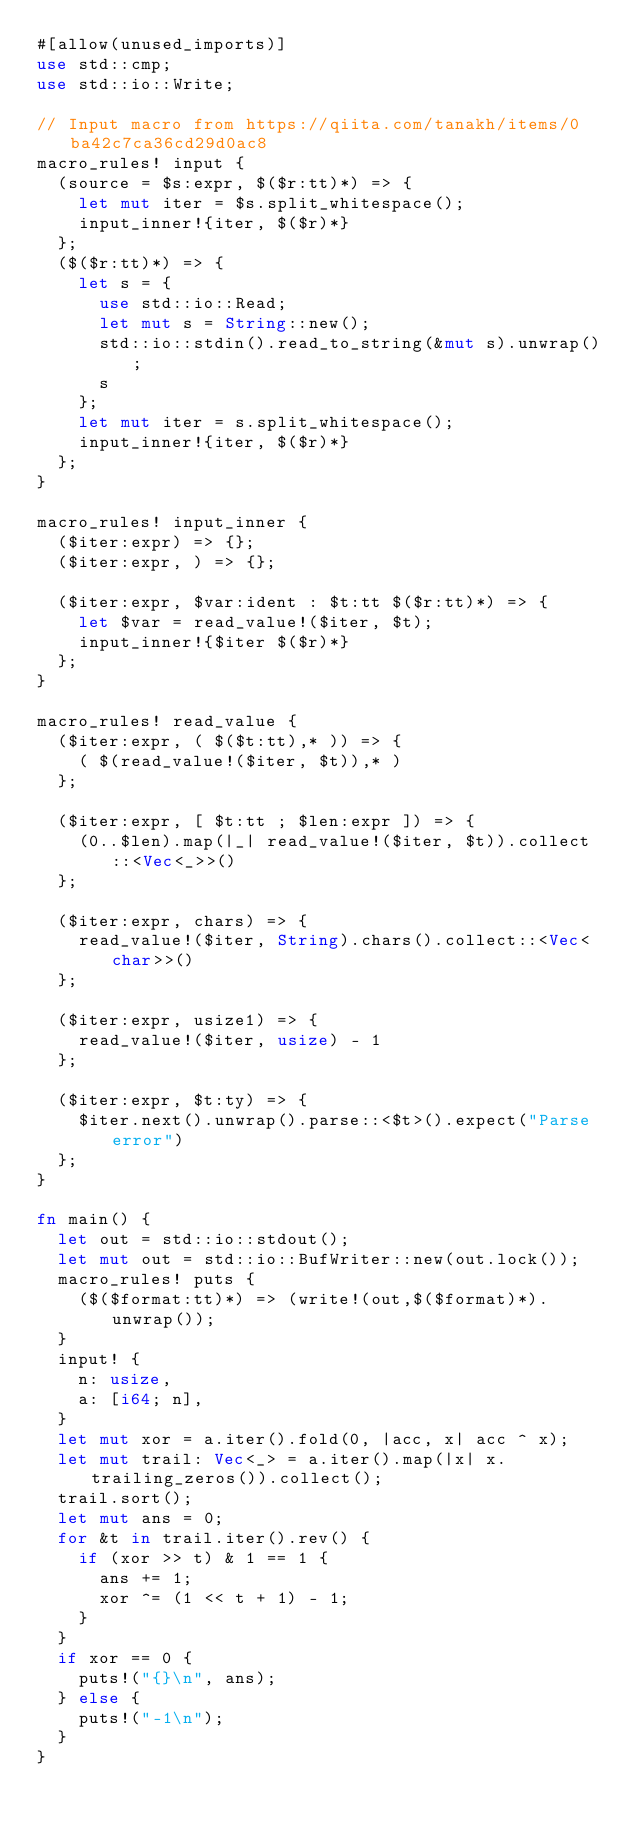Convert code to text. <code><loc_0><loc_0><loc_500><loc_500><_Rust_>#[allow(unused_imports)]
use std::cmp;
use std::io::Write;

// Input macro from https://qiita.com/tanakh/items/0ba42c7ca36cd29d0ac8
macro_rules! input {
  (source = $s:expr, $($r:tt)*) => {
    let mut iter = $s.split_whitespace();
    input_inner!{iter, $($r)*}
  };
  ($($r:tt)*) => {
    let s = {
      use std::io::Read;
      let mut s = String::new();
      std::io::stdin().read_to_string(&mut s).unwrap();
      s
    };
    let mut iter = s.split_whitespace();
    input_inner!{iter, $($r)*}
  };
}

macro_rules! input_inner {
  ($iter:expr) => {};
  ($iter:expr, ) => {};

  ($iter:expr, $var:ident : $t:tt $($r:tt)*) => {
    let $var = read_value!($iter, $t);
    input_inner!{$iter $($r)*}
  };
}

macro_rules! read_value {
  ($iter:expr, ( $($t:tt),* )) => {
    ( $(read_value!($iter, $t)),* )
  };

  ($iter:expr, [ $t:tt ; $len:expr ]) => {
    (0..$len).map(|_| read_value!($iter, $t)).collect::<Vec<_>>()
  };

  ($iter:expr, chars) => {
    read_value!($iter, String).chars().collect::<Vec<char>>()
  };

  ($iter:expr, usize1) => {
    read_value!($iter, usize) - 1
  };

  ($iter:expr, $t:ty) => {
    $iter.next().unwrap().parse::<$t>().expect("Parse error")
  };
}

fn main() {
  let out = std::io::stdout();
  let mut out = std::io::BufWriter::new(out.lock());
  macro_rules! puts {
    ($($format:tt)*) => (write!(out,$($format)*).unwrap());
  }
  input! {
    n: usize,
    a: [i64; n],
  }
  let mut xor = a.iter().fold(0, |acc, x| acc ^ x);
  let mut trail: Vec<_> = a.iter().map(|x| x.trailing_zeros()).collect();
  trail.sort();
  let mut ans = 0;
  for &t in trail.iter().rev() {
    if (xor >> t) & 1 == 1 {
      ans += 1;
      xor ^= (1 << t + 1) - 1;
    }
  }
  if xor == 0 {
    puts!("{}\n", ans);
  } else {
    puts!("-1\n");
  }
}
</code> 